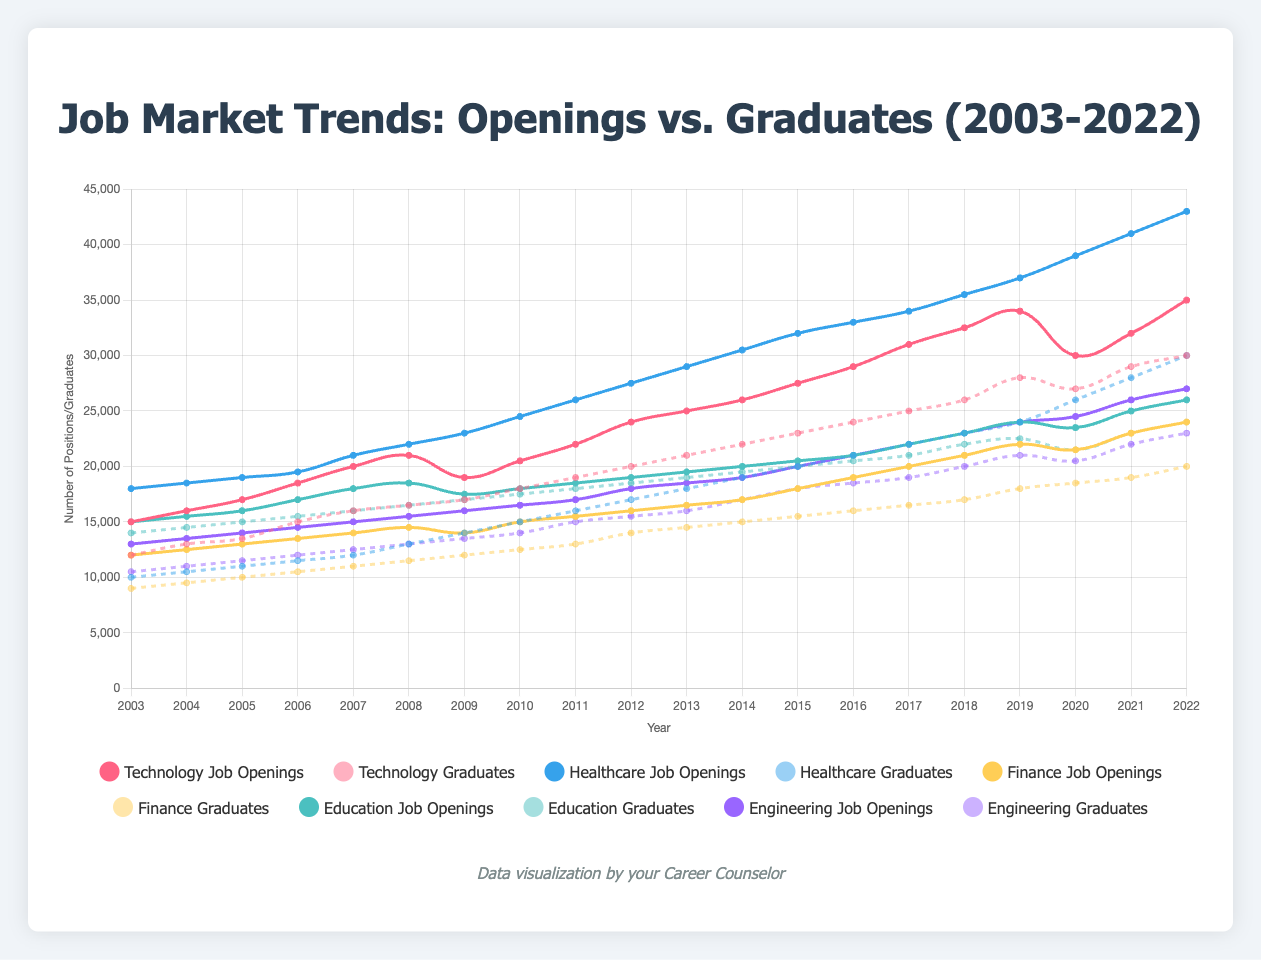What sector had the highest increase in job openings from 2003 to 2022? To find the sector with the highest increase, we need to calculate the difference between job openings in 2022 and 2003 for each sector:
- Technology: 35000 - 15000 = 20000
- Healthcare: 43000 - 18000 = 25000
- Finance: 24000 - 12000 = 12000
- Education: 26000 - 15000 = 11000
- Engineering: 27000 - 13000 = 14000
Healthcare has the highest increase.
Answer: Healthcare Which sector had more job openings than graduates in 2022? We compare the job openings and graduates for each sector in 2022:
- Technology: 35000 openings vs. 30000 graduates
- Healthcare: 43000 openings vs. 30000 graduates
- Finance: 24000 openings vs. 20000 graduates
- Education: 26000 openings vs. 24000 graduates
- Engineering: 27000 openings vs. 23000 graduates
All sectors had more job openings than graduates in 2022.
Answer: All sectors By how much did Healthcare job openings exceed Finance job openings in 2022? We subtract the number of Finance job openings from Healthcare job openings in 2022:
43000 (Healthcare) - 24000 (Finance) = 19000.
Answer: 19000 In which year did Technology job openings surpass 30000? Observing the Technology job openings line, we see it surpasses 30000 in 2017.
Answer: 2017 What is the average number of graduates in the Engineering sector from 2003 to 2022? To find the average, sum the number of graduates from 2003 to 2022 and divide by the number of years (20):
(10500 + 11000 + 11500 + 12000 + 12500 + 13000 + 13500 + 14000 + 15000 + 15500 + 16000 + 17000 + 18000 + 18500 + 19000 + 20000 + 21000 + 20500 + 22000 + 23000) / 20 = 15600.
Answer: 15600 Which sector had the smallest gap between job openings and graduates in 2021? Calculating the differences between job openings and graduates for each sector in 2021:
- Technology: 32000 - 29000 = 3000
- Healthcare: 41000 - 28000 = 13000
- Finance: 23000 - 19000 = 4000
- Education: 25000 - 23000 = 2000
- Engineering: 26000 - 22000 = 4000
Education had the smallest gap of 2000.
Answer: Education In what year did Finance have more graduates than job openings for the first time? Observing the Finance sector's lines, graduates surpass job openings for the first time in 2019.
Answer: 2019 What is the difference in the number of graduates between the first and last year for the Technology sector? Subtracting the number of graduates in 2003 from the number in 2022 for Technology:
30000 (2022) - 12000 (2003) = 18000.
Answer: 18000 